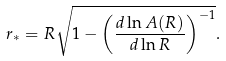<formula> <loc_0><loc_0><loc_500><loc_500>r _ { * } = R \sqrt { 1 - \left ( \frac { d \ln A ( R ) } { d \ln R } \right ) ^ { - 1 } } . \</formula> 